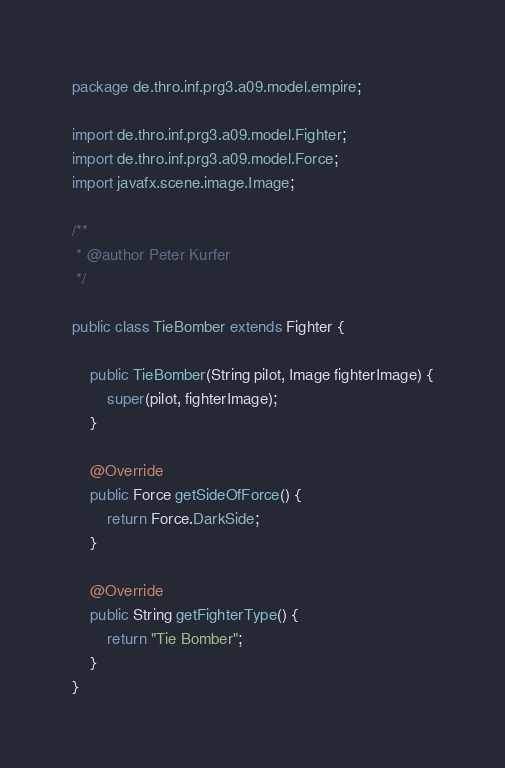Convert code to text. <code><loc_0><loc_0><loc_500><loc_500><_Java_>package de.thro.inf.prg3.a09.model.empire;

import de.thro.inf.prg3.a09.model.Fighter;
import de.thro.inf.prg3.a09.model.Force;
import javafx.scene.image.Image;

/**
 * @author Peter Kurfer
 */

public class TieBomber extends Fighter {

	public TieBomber(String pilot, Image fighterImage) {
		super(pilot, fighterImage);
	}

	@Override
	public Force getSideOfForce() {
		return Force.DarkSide;
	}

	@Override
	public String getFighterType() {
		return "Tie Bomber";
	}
}
</code> 